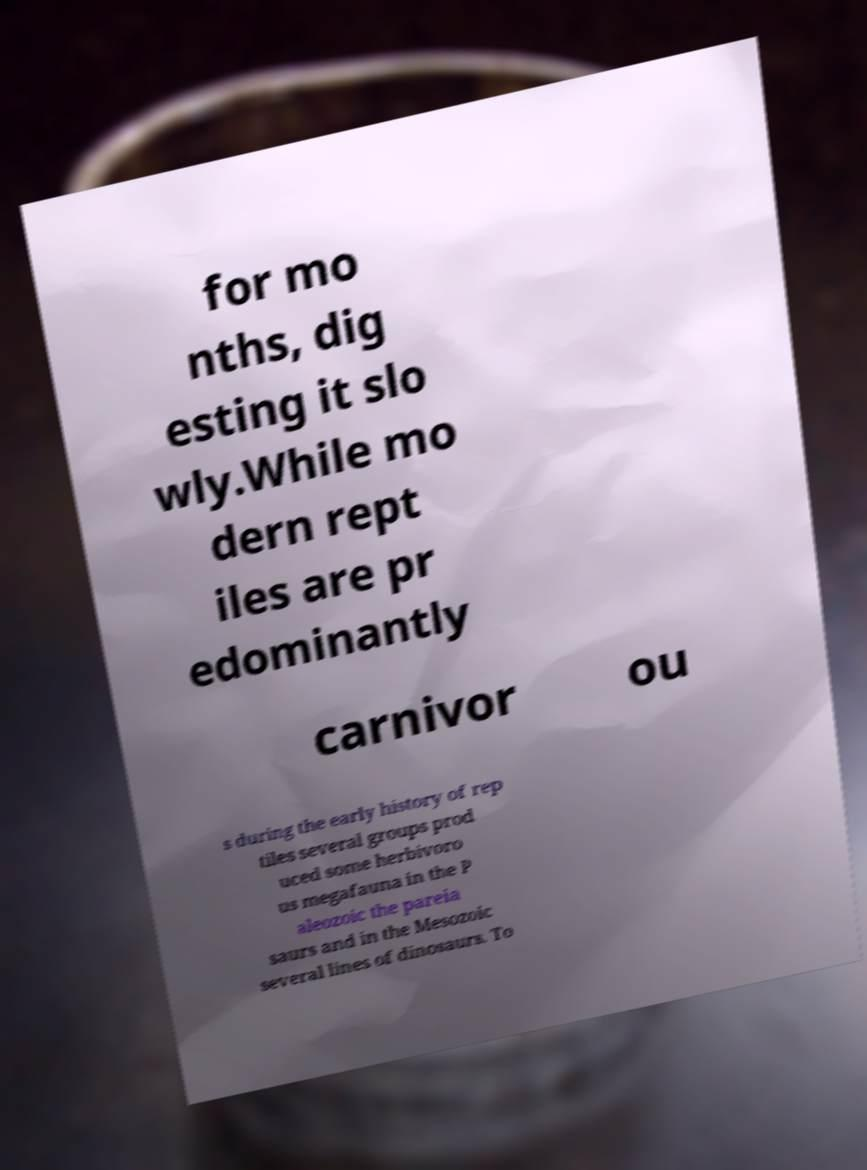For documentation purposes, I need the text within this image transcribed. Could you provide that? for mo nths, dig esting it slo wly.While mo dern rept iles are pr edominantly carnivor ou s during the early history of rep tiles several groups prod uced some herbivoro us megafauna in the P aleozoic the pareia saurs and in the Mesozoic several lines of dinosaurs. To 